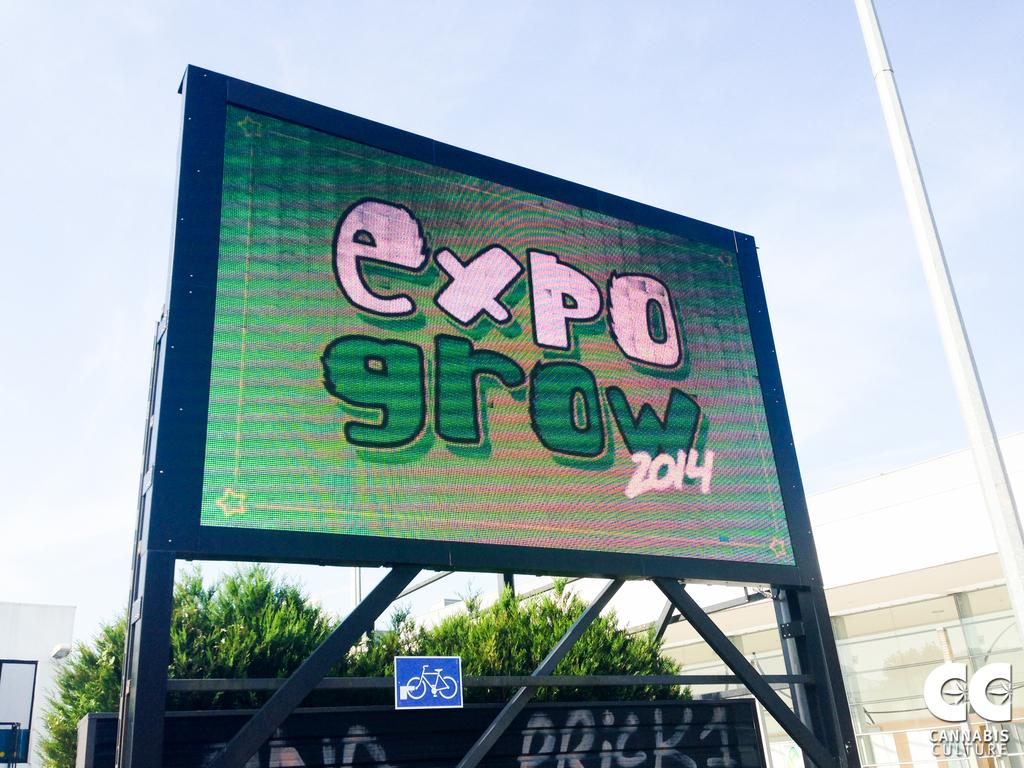<image>
Share a concise interpretation of the image provided. a sign that says expo grown 2014 in pink and green 